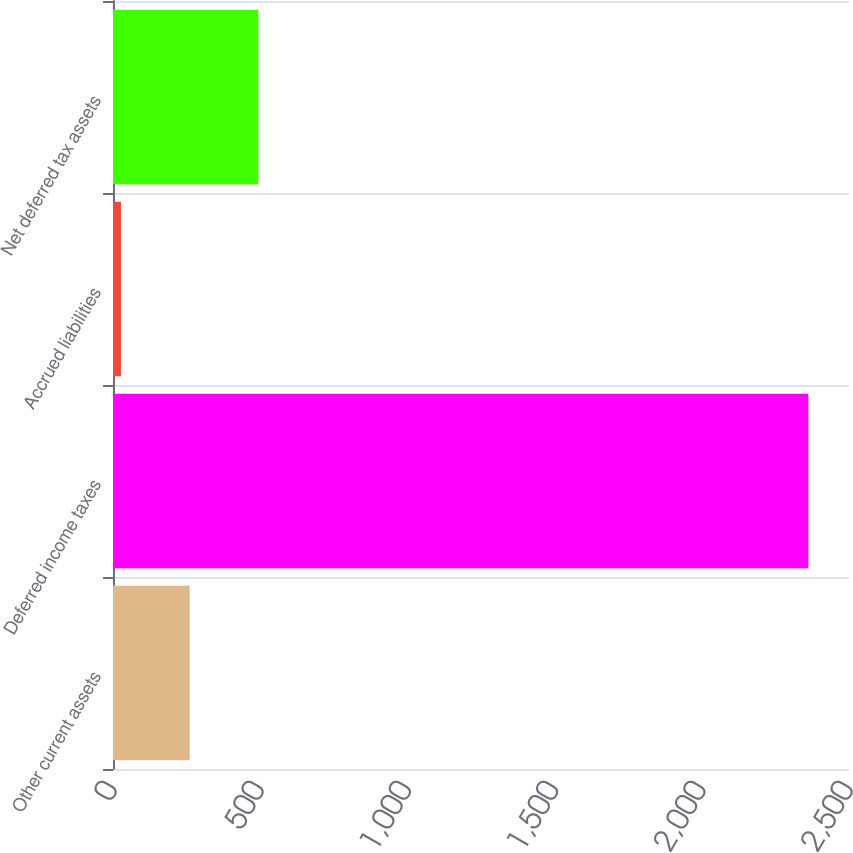Convert chart. <chart><loc_0><loc_0><loc_500><loc_500><bar_chart><fcel>Other current assets<fcel>Deferred income taxes<fcel>Accrued liabilities<fcel>Net deferred tax assets<nl><fcel>260.5<fcel>2362<fcel>27<fcel>494<nl></chart> 